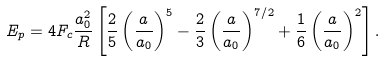<formula> <loc_0><loc_0><loc_500><loc_500>E _ { p } = 4 F _ { c } \frac { a _ { 0 } ^ { 2 } } { R } \left [ \frac { 2 } { 5 } \left ( \frac { a } { a _ { 0 } } \right ) ^ { 5 } - \frac { 2 } { 3 } \left ( \frac { a } { a _ { 0 } } \right ) ^ { 7 / 2 } + \frac { 1 } { 6 } \left ( \frac { a } { a _ { 0 } } \right ) ^ { 2 } \right ] .</formula> 